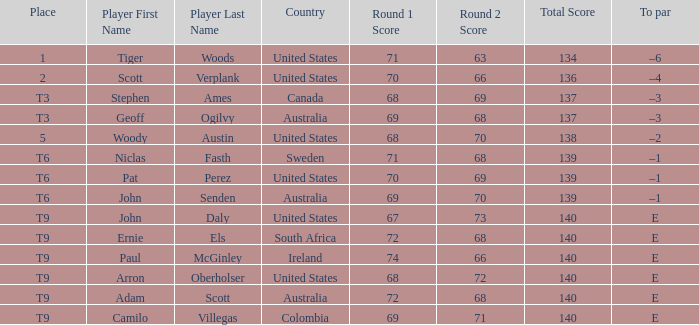Which player has a to par of e and a score of 67-73=140? John Daly. 